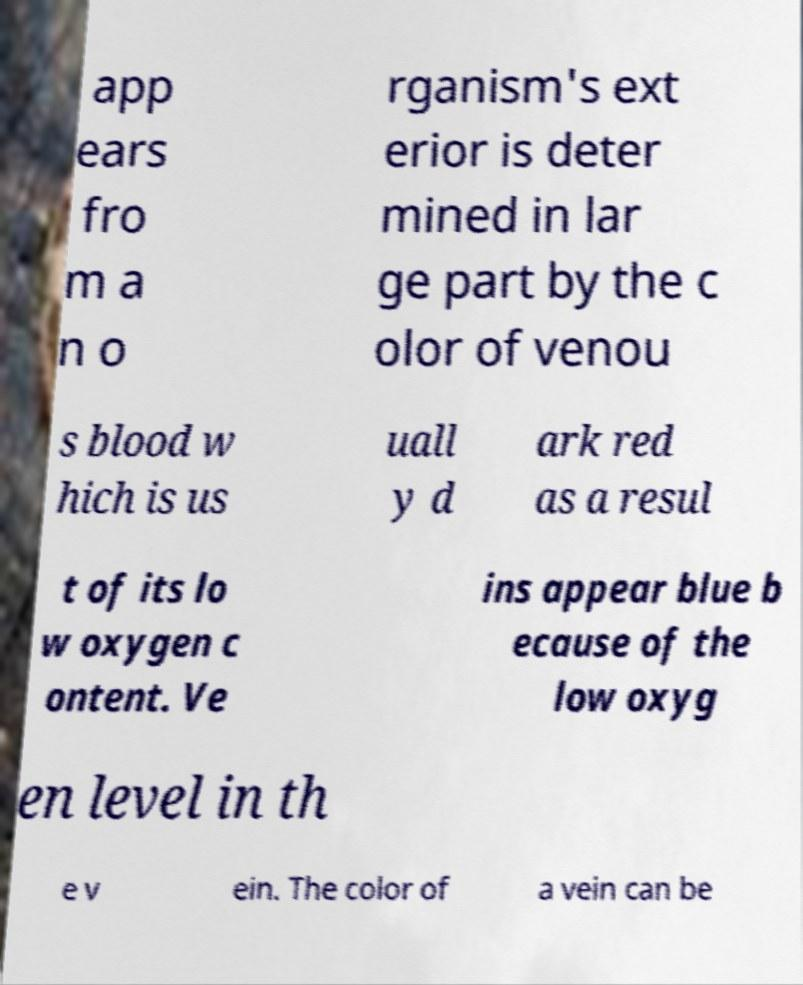Could you extract and type out the text from this image? app ears fro m a n o rganism's ext erior is deter mined in lar ge part by the c olor of venou s blood w hich is us uall y d ark red as a resul t of its lo w oxygen c ontent. Ve ins appear blue b ecause of the low oxyg en level in th e v ein. The color of a vein can be 